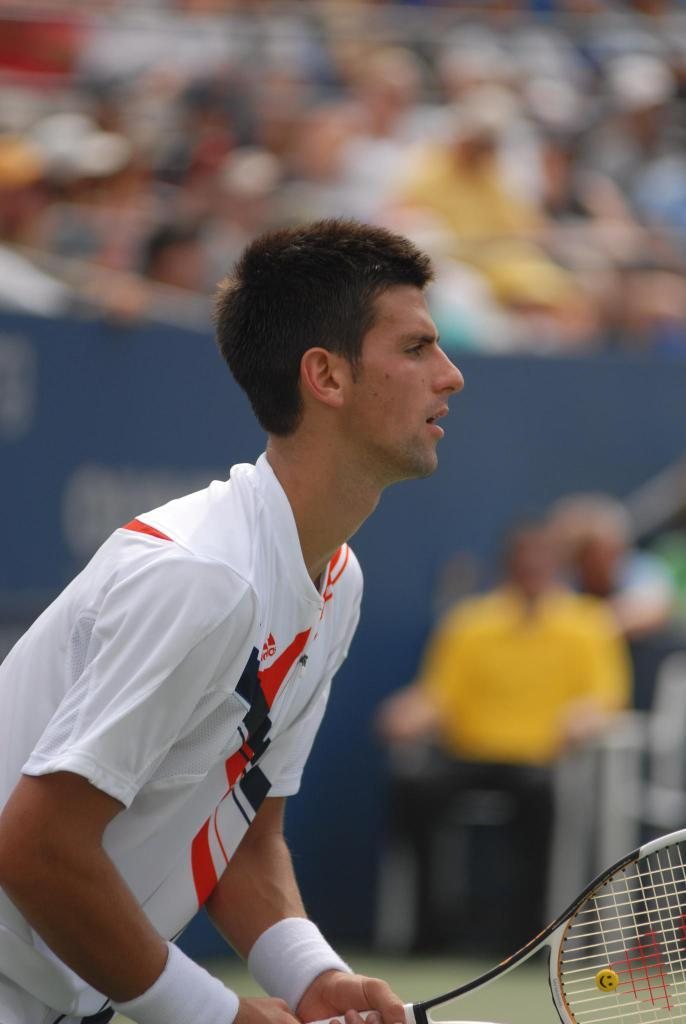What is the main subject of the image? There is a man in the image. What is the man holding in the image? The man is holding a shuttle bat. Can you describe the background of the image? The background of the image is blurry. What type of mint can be seen growing in the background of the image? There is no mint present in the image, and the background is blurry, so it is not possible to determine if any plants are growing there. 